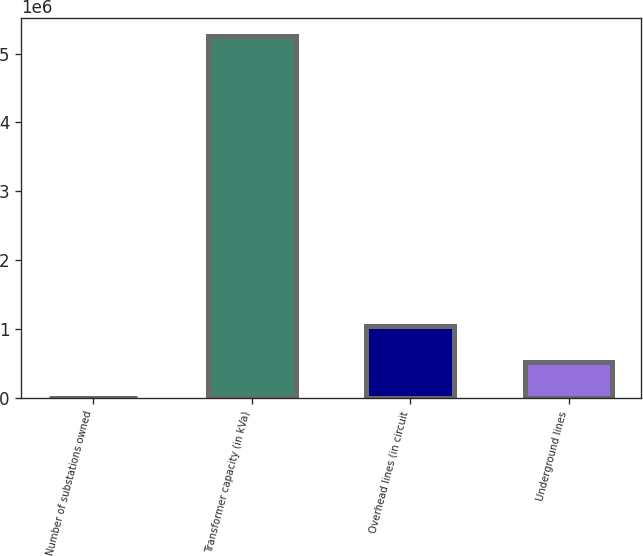<chart> <loc_0><loc_0><loc_500><loc_500><bar_chart><fcel>Number of substations owned<fcel>Transformer capacity (in kVa)<fcel>Overhead lines (in circuit<fcel>Underground lines<nl><fcel>154<fcel>5.257e+06<fcel>1.05152e+06<fcel>525839<nl></chart> 